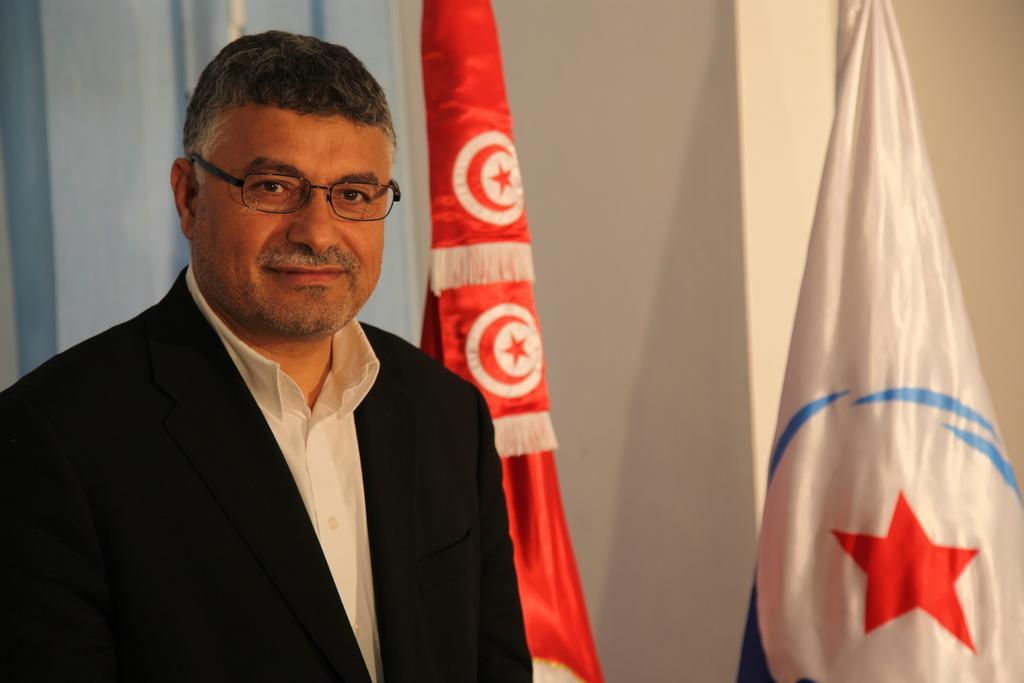How would you summarize this image in a sentence or two? In this image, I can see a man smiling. On the right side of the image, there are two flags. In the background, there is the wall. 